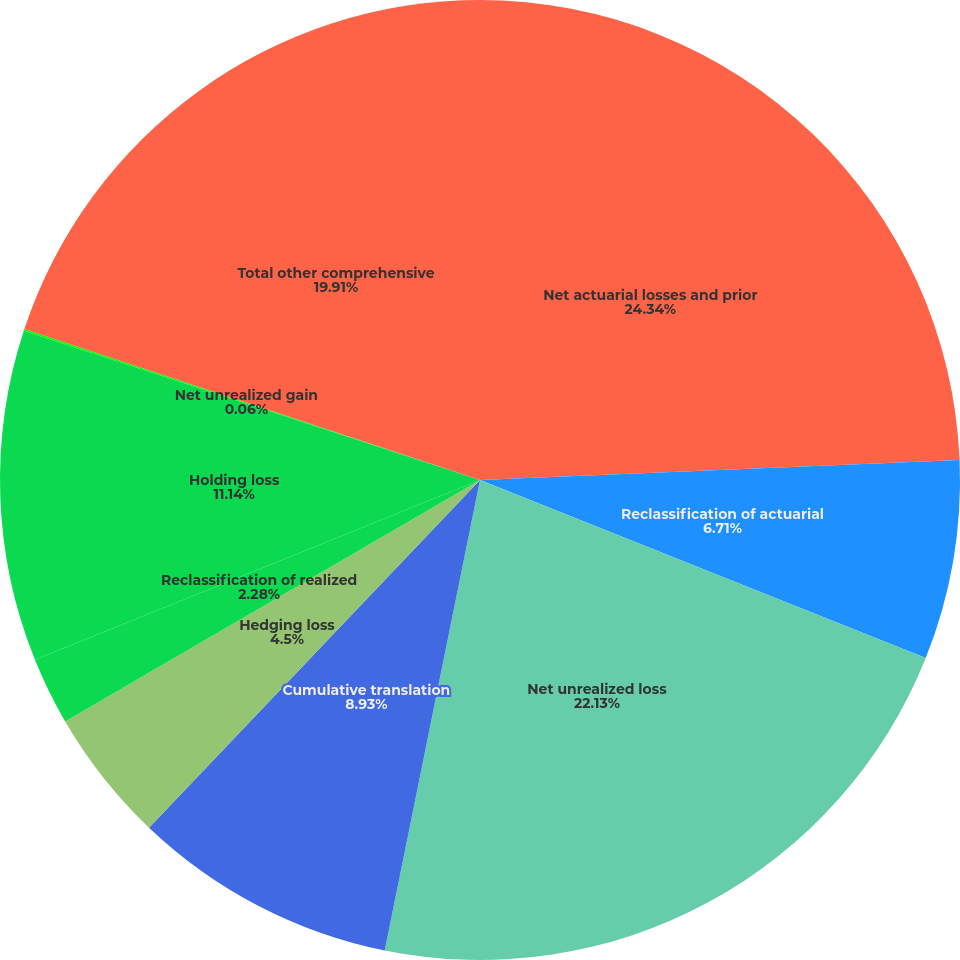<chart> <loc_0><loc_0><loc_500><loc_500><pie_chart><fcel>Net actuarial losses and prior<fcel>Reclassification of actuarial<fcel>Net unrealized loss<fcel>Cumulative translation<fcel>Hedging loss<fcel>Reclassification of realized<fcel>Holding loss<fcel>Net unrealized gain<fcel>Total other comprehensive<nl><fcel>24.34%<fcel>6.71%<fcel>22.13%<fcel>8.93%<fcel>4.5%<fcel>2.28%<fcel>11.14%<fcel>0.06%<fcel>19.91%<nl></chart> 